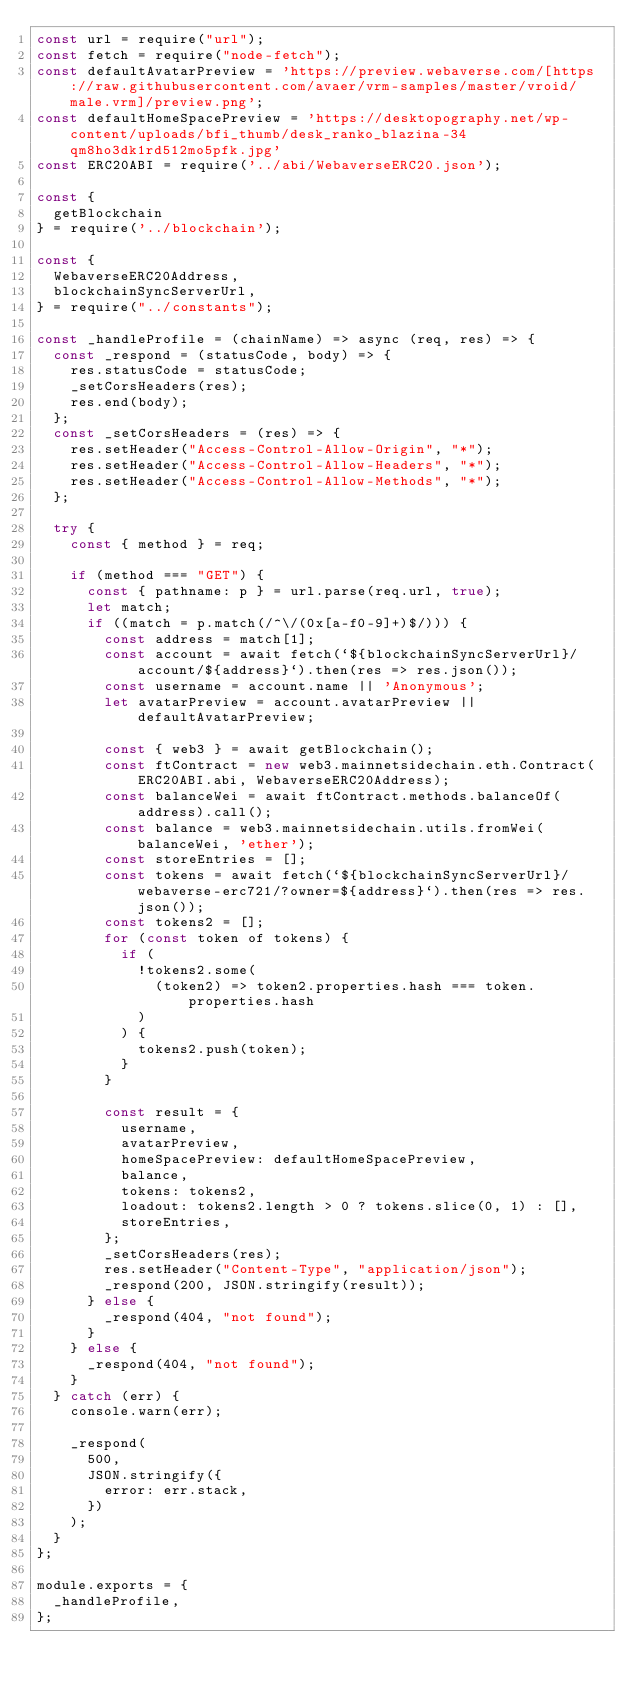<code> <loc_0><loc_0><loc_500><loc_500><_JavaScript_>const url = require("url");
const fetch = require("node-fetch");
const defaultAvatarPreview = 'https://preview.webaverse.com/[https://raw.githubusercontent.com/avaer/vrm-samples/master/vroid/male.vrm]/preview.png';
const defaultHomeSpacePreview = 'https://desktopography.net/wp-content/uploads/bfi_thumb/desk_ranko_blazina-34qm8ho3dk1rd512mo5pfk.jpg'
const ERC20ABI = require('../abi/WebaverseERC20.json');

const {
  getBlockchain
} = require('../blockchain');

const {
  WebaverseERC20Address,
  blockchainSyncServerUrl,
} = require("../constants");

const _handleProfile = (chainName) => async (req, res) => {
  const _respond = (statusCode, body) => {
    res.statusCode = statusCode;
    _setCorsHeaders(res);
    res.end(body);
  };
  const _setCorsHeaders = (res) => {
    res.setHeader("Access-Control-Allow-Origin", "*");
    res.setHeader("Access-Control-Allow-Headers", "*");
    res.setHeader("Access-Control-Allow-Methods", "*");
  };

  try {
    const { method } = req;

    if (method === "GET") {
      const { pathname: p } = url.parse(req.url, true);
      let match;
      if ((match = p.match(/^\/(0x[a-f0-9]+)$/))) {
        const address = match[1];
        const account = await fetch(`${blockchainSyncServerUrl}/account/${address}`).then(res => res.json());
        const username = account.name || 'Anonymous';
        let avatarPreview = account.avatarPreview || defaultAvatarPreview;

        const { web3 } = await getBlockchain();
        const ftContract = new web3.mainnetsidechain.eth.Contract(ERC20ABI.abi, WebaverseERC20Address);
        const balanceWei = await ftContract.methods.balanceOf(address).call();
        const balance = web3.mainnetsidechain.utils.fromWei(balanceWei, 'ether');
        const storeEntries = [];
        const tokens = await fetch(`${blockchainSyncServerUrl}/webaverse-erc721/?owner=${address}`).then(res => res.json());
        const tokens2 = [];
        for (const token of tokens) {
          if (
            !tokens2.some(
              (token2) => token2.properties.hash === token.properties.hash
            )
          ) {
            tokens2.push(token);
          }
        }

        const result = {
          username,
          avatarPreview,
          homeSpacePreview: defaultHomeSpacePreview,
          balance,
          tokens: tokens2,
          loadout: tokens2.length > 0 ? tokens.slice(0, 1) : [],
          storeEntries,
        };
        _setCorsHeaders(res);
        res.setHeader("Content-Type", "application/json");
        _respond(200, JSON.stringify(result));
      } else {
        _respond(404, "not found");
      }
    } else {
      _respond(404, "not found");
    }
  } catch (err) {
    console.warn(err);

    _respond(
      500,
      JSON.stringify({
        error: err.stack,
      })
    );
  }
};

module.exports = {
  _handleProfile,
};</code> 